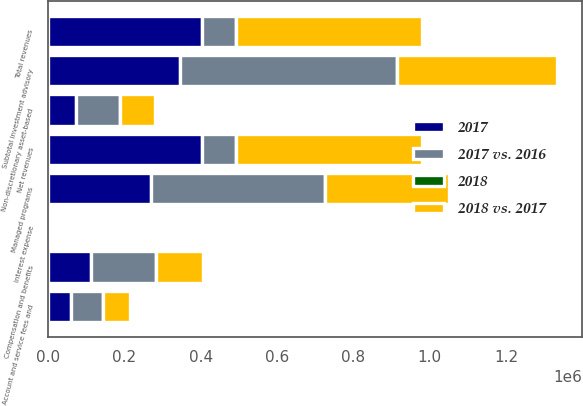Convert chart. <chart><loc_0><loc_0><loc_500><loc_500><stacked_bar_chart><ecel><fcel>Managed programs<fcel>Non-discretionary asset-based<fcel>Subtotal investment advisory<fcel>Account and service fees and<fcel>Total revenues<fcel>Interest expense<fcel>Net revenues<fcel>Compensation and benefits<nl><fcel>2017 vs. 2016<fcel>454027<fcel>115562<fcel>569589<fcel>84829<fcel>87958<fcel>41<fcel>87958<fcel>169993<nl><fcel>2018 vs. 2017<fcel>326405<fcel>91087<fcel>417492<fcel>70243<fcel>487735<fcel>77<fcel>487658<fcel>123119<nl><fcel>2017<fcel>270623<fcel>74130<fcel>344753<fcel>59668<fcel>404421<fcel>72<fcel>404349<fcel>112998<nl><fcel>2018<fcel>39<fcel>27<fcel>36<fcel>21<fcel>34<fcel>47<fcel>34<fcel>38<nl></chart> 